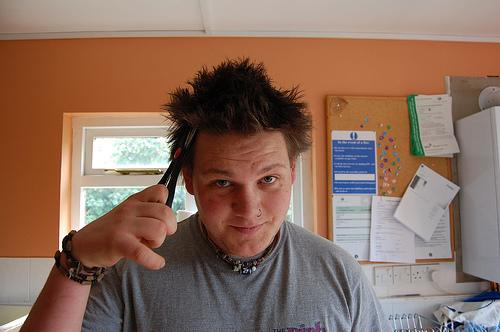What is the color and style of the man's clothing? The man is wearing a grey tee shirt. Count the number of unused thumbtacks visible in the image. There is an assortment of unused thumbtacks. What is the appearance of the bulletin board in the image? The bulletin board is covered with assorted papers, including green-edged and mostly blue paperwork. Briefly describe the hairstyle of the man in the image. The man has dark, spiked hair standing on end, which appears to be long and messy. What is the color of the wall in the image? The wall is painted orange. Identify the type of accessory the man has in his nose. The man has a hoop ring in his left nostril. Could you provide a description of the ceiling in the image? The ceiling is white and appears to be made of dropped ceiling tiles. Please list the types of jewelry the man is wearing in the image. The man is wearing a beaded bracelet on his wrist and a beaded necklace around his neck. Can you tell me what the man is doing in the image? The man is holding a pair of scissors to his hair, attempting to give himself a haircut. What is the condition of the window behind the man? The window behind the man is closed and has a white frame. Locate the hoop ring in the image. In the man's left nostril What activity is the man performing? Giving himself a haircut List the main colors of the papers on the bulletin board. blue, green, and white Describe the emotion visible on the man's face. neutral, no strong emotion Is there a silver hoop earring on the man's ear? No, it's not mentioned in the image. Write a short descriptive sentence about what the man is doing. The man is holding a pair of scissors to his hair, ready to give himself a haircut. What is the top-left object in the image? white ceiling tiles What color is the guy's shirt? grey Identify the material on the corkboard. An assortment of unused thumbtacks and mostly blue, green, and white paperwork List the accessories the man is wearing. Beaded bracelet, beaded necklace, and a hoop ring in his nose Describe the hairstyle of the man. Messy, dark, and spiked Choose the correct description of the guy's bracelet: a) a gold watch b) a bead bracelet c) a leather wristband a bead bracelet What type of document layout is on the corkboard? Papers arranged in an assortment Which of these is seen in the image? a) an open window b) a closed window c) no window b) a closed window Is the man wearing a bright yellow shirt? The man is actually wearing a grey tee shirt, so mentioning a yellow shirt would be misleading. Identify and describe the picture's main background presence. An orange painted wall Describe the state of the man's hair. Messy, long, and standing on end What does the man plan to do with the scissors? Cut his hair What color is the wall in the image? orange What facial feature of the man is unique? Hoop ring in his left nostril Based on the picture, what is mounted near the ceiling? A dropped ceiling What type of ceiling is in the image? A dropped ceiling with white tiles 